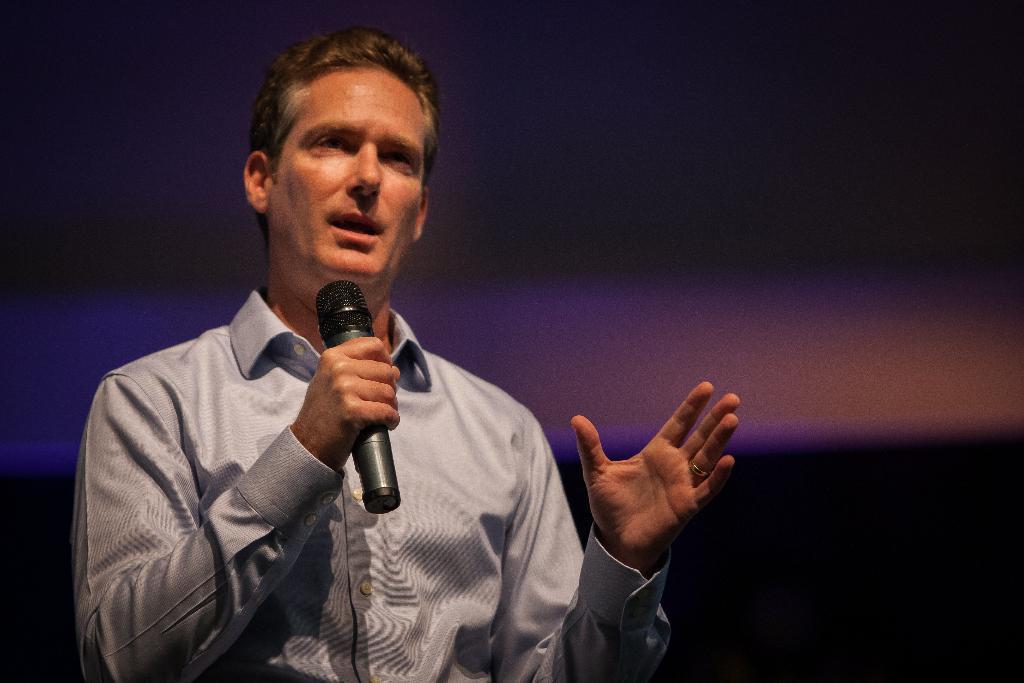Describe this image in one or two sentences. In this image we can see a person holding mic and speaking. In the background it is blur. 